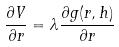<formula> <loc_0><loc_0><loc_500><loc_500>\frac { \partial V } { \partial r } = \lambda \frac { \partial g ( r , h ) } { \partial r }</formula> 